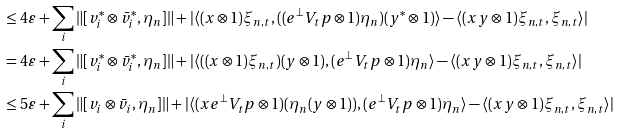Convert formula to latex. <formula><loc_0><loc_0><loc_500><loc_500>& \leq 4 \varepsilon + \sum _ { i } \| [ v ^ { * } _ { i } \otimes \bar { v } ^ { * } _ { i } , \eta _ { n } ] \| + | \langle ( x \otimes 1 ) \xi _ { n , t } , ( ( e ^ { \perp } V _ { t } p \otimes 1 ) \eta _ { n } ) ( y ^ { * } \otimes 1 ) \rangle - \langle ( x y \otimes 1 ) \xi _ { n , t } , \xi _ { n , t } \rangle | \\ & = 4 \varepsilon + \sum _ { i } \| [ v ^ { * } _ { i } \otimes \bar { v } ^ { * } _ { i } , \eta _ { n } ] \| + | \langle ( ( x \otimes 1 ) \xi _ { n , t } ) ( y \otimes 1 ) , ( e ^ { \perp } V _ { t } p \otimes 1 ) \eta _ { n } \rangle - \langle ( x y \otimes 1 ) \xi _ { n , t } , \xi _ { n , t } \rangle | \\ & \leq 5 \varepsilon + \sum _ { i } \| [ v _ { i } \otimes \bar { v } _ { i } , \eta _ { n } ] \| + | \langle ( x e ^ { \perp } V _ { t } p \otimes 1 ) ( \eta _ { n } ( y \otimes 1 ) ) , ( e ^ { \perp } V _ { t } p \otimes 1 ) \eta _ { n } \rangle - \langle ( x y \otimes 1 ) \xi _ { n , t } , \xi _ { n , t } \rangle |</formula> 